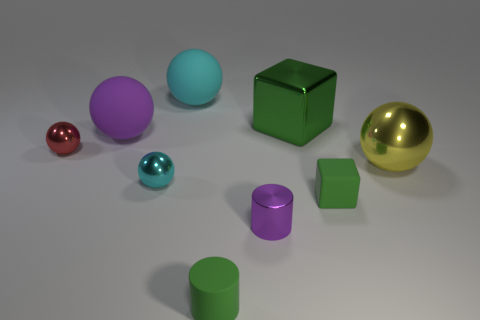Subtract all gray balls. Subtract all red cylinders. How many balls are left? 5 Add 1 big green metallic blocks. How many objects exist? 10 Subtract all cylinders. How many objects are left? 7 Subtract 0 blue cylinders. How many objects are left? 9 Subtract all red objects. Subtract all big purple metallic balls. How many objects are left? 8 Add 2 tiny matte objects. How many tiny matte objects are left? 4 Add 6 green things. How many green things exist? 9 